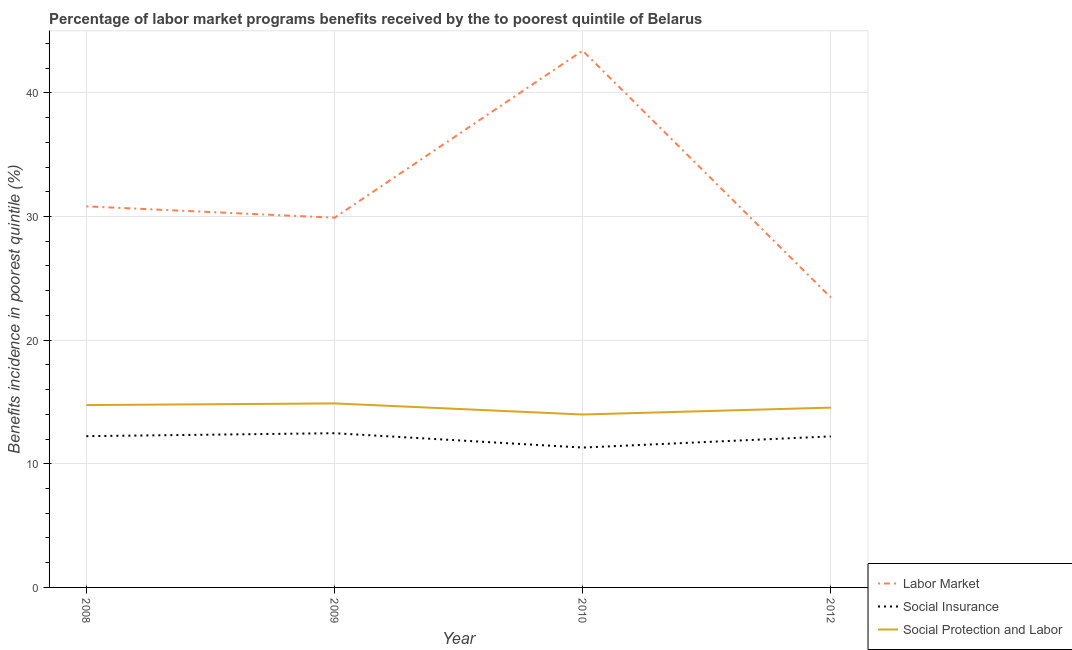What is the percentage of benefits received due to labor market programs in 2008?
Your answer should be compact. 30.82. Across all years, what is the maximum percentage of benefits received due to social insurance programs?
Provide a short and direct response. 12.47. Across all years, what is the minimum percentage of benefits received due to labor market programs?
Your answer should be compact. 23.45. In which year was the percentage of benefits received due to social insurance programs minimum?
Your response must be concise. 2010. What is the total percentage of benefits received due to social insurance programs in the graph?
Your answer should be compact. 48.24. What is the difference between the percentage of benefits received due to social protection programs in 2009 and that in 2010?
Make the answer very short. 0.9. What is the difference between the percentage of benefits received due to social protection programs in 2012 and the percentage of benefits received due to social insurance programs in 2010?
Provide a short and direct response. 3.23. What is the average percentage of benefits received due to social protection programs per year?
Provide a succinct answer. 14.54. In the year 2010, what is the difference between the percentage of benefits received due to labor market programs and percentage of benefits received due to social protection programs?
Ensure brevity in your answer.  29.43. In how many years, is the percentage of benefits received due to labor market programs greater than 8 %?
Keep it short and to the point. 4. What is the ratio of the percentage of benefits received due to social protection programs in 2008 to that in 2010?
Make the answer very short. 1.05. Is the percentage of benefits received due to social insurance programs in 2008 less than that in 2010?
Your response must be concise. No. What is the difference between the highest and the second highest percentage of benefits received due to labor market programs?
Your response must be concise. 12.59. What is the difference between the highest and the lowest percentage of benefits received due to labor market programs?
Offer a very short reply. 19.96. In how many years, is the percentage of benefits received due to labor market programs greater than the average percentage of benefits received due to labor market programs taken over all years?
Your answer should be compact. 1. Does the percentage of benefits received due to social insurance programs monotonically increase over the years?
Offer a terse response. No. Is the percentage of benefits received due to labor market programs strictly greater than the percentage of benefits received due to social protection programs over the years?
Your answer should be very brief. Yes. Is the percentage of benefits received due to social insurance programs strictly less than the percentage of benefits received due to social protection programs over the years?
Offer a terse response. Yes. How many lines are there?
Offer a terse response. 3. How many years are there in the graph?
Provide a succinct answer. 4. Are the values on the major ticks of Y-axis written in scientific E-notation?
Offer a terse response. No. Does the graph contain any zero values?
Provide a succinct answer. No. Does the graph contain grids?
Keep it short and to the point. Yes. Where does the legend appear in the graph?
Your answer should be very brief. Bottom right. How many legend labels are there?
Your response must be concise. 3. How are the legend labels stacked?
Make the answer very short. Vertical. What is the title of the graph?
Make the answer very short. Percentage of labor market programs benefits received by the to poorest quintile of Belarus. What is the label or title of the Y-axis?
Provide a succinct answer. Benefits incidence in poorest quintile (%). What is the Benefits incidence in poorest quintile (%) in Labor Market in 2008?
Offer a terse response. 30.82. What is the Benefits incidence in poorest quintile (%) in Social Insurance in 2008?
Provide a succinct answer. 12.24. What is the Benefits incidence in poorest quintile (%) of Social Protection and Labor in 2008?
Offer a very short reply. 14.75. What is the Benefits incidence in poorest quintile (%) in Labor Market in 2009?
Provide a short and direct response. 29.9. What is the Benefits incidence in poorest quintile (%) of Social Insurance in 2009?
Provide a short and direct response. 12.47. What is the Benefits incidence in poorest quintile (%) in Social Protection and Labor in 2009?
Offer a terse response. 14.89. What is the Benefits incidence in poorest quintile (%) of Labor Market in 2010?
Provide a succinct answer. 43.42. What is the Benefits incidence in poorest quintile (%) of Social Insurance in 2010?
Provide a succinct answer. 11.31. What is the Benefits incidence in poorest quintile (%) in Social Protection and Labor in 2010?
Offer a very short reply. 13.99. What is the Benefits incidence in poorest quintile (%) in Labor Market in 2012?
Make the answer very short. 23.45. What is the Benefits incidence in poorest quintile (%) of Social Insurance in 2012?
Your response must be concise. 12.22. What is the Benefits incidence in poorest quintile (%) in Social Protection and Labor in 2012?
Offer a terse response. 14.54. Across all years, what is the maximum Benefits incidence in poorest quintile (%) in Labor Market?
Provide a succinct answer. 43.42. Across all years, what is the maximum Benefits incidence in poorest quintile (%) in Social Insurance?
Give a very brief answer. 12.47. Across all years, what is the maximum Benefits incidence in poorest quintile (%) of Social Protection and Labor?
Ensure brevity in your answer.  14.89. Across all years, what is the minimum Benefits incidence in poorest quintile (%) in Labor Market?
Your answer should be compact. 23.45. Across all years, what is the minimum Benefits incidence in poorest quintile (%) of Social Insurance?
Give a very brief answer. 11.31. Across all years, what is the minimum Benefits incidence in poorest quintile (%) of Social Protection and Labor?
Provide a short and direct response. 13.99. What is the total Benefits incidence in poorest quintile (%) of Labor Market in the graph?
Provide a succinct answer. 127.6. What is the total Benefits incidence in poorest quintile (%) in Social Insurance in the graph?
Your response must be concise. 48.24. What is the total Benefits incidence in poorest quintile (%) in Social Protection and Labor in the graph?
Keep it short and to the point. 58.16. What is the difference between the Benefits incidence in poorest quintile (%) in Labor Market in 2008 and that in 2009?
Your response must be concise. 0.92. What is the difference between the Benefits incidence in poorest quintile (%) in Social Insurance in 2008 and that in 2009?
Your answer should be compact. -0.24. What is the difference between the Benefits incidence in poorest quintile (%) of Social Protection and Labor in 2008 and that in 2009?
Your answer should be very brief. -0.14. What is the difference between the Benefits incidence in poorest quintile (%) of Labor Market in 2008 and that in 2010?
Your answer should be compact. -12.59. What is the difference between the Benefits incidence in poorest quintile (%) in Social Insurance in 2008 and that in 2010?
Your answer should be compact. 0.92. What is the difference between the Benefits incidence in poorest quintile (%) in Social Protection and Labor in 2008 and that in 2010?
Your answer should be very brief. 0.76. What is the difference between the Benefits incidence in poorest quintile (%) of Labor Market in 2008 and that in 2012?
Provide a short and direct response. 7.37. What is the difference between the Benefits incidence in poorest quintile (%) in Social Insurance in 2008 and that in 2012?
Offer a very short reply. 0.02. What is the difference between the Benefits incidence in poorest quintile (%) in Social Protection and Labor in 2008 and that in 2012?
Keep it short and to the point. 0.2. What is the difference between the Benefits incidence in poorest quintile (%) in Labor Market in 2009 and that in 2010?
Offer a terse response. -13.51. What is the difference between the Benefits incidence in poorest quintile (%) in Social Insurance in 2009 and that in 2010?
Your answer should be compact. 1.16. What is the difference between the Benefits incidence in poorest quintile (%) in Social Protection and Labor in 2009 and that in 2010?
Your answer should be compact. 0.9. What is the difference between the Benefits incidence in poorest quintile (%) in Labor Market in 2009 and that in 2012?
Ensure brevity in your answer.  6.45. What is the difference between the Benefits incidence in poorest quintile (%) in Social Insurance in 2009 and that in 2012?
Offer a very short reply. 0.26. What is the difference between the Benefits incidence in poorest quintile (%) in Social Protection and Labor in 2009 and that in 2012?
Offer a very short reply. 0.34. What is the difference between the Benefits incidence in poorest quintile (%) in Labor Market in 2010 and that in 2012?
Give a very brief answer. 19.96. What is the difference between the Benefits incidence in poorest quintile (%) in Social Insurance in 2010 and that in 2012?
Provide a succinct answer. -0.9. What is the difference between the Benefits incidence in poorest quintile (%) in Social Protection and Labor in 2010 and that in 2012?
Give a very brief answer. -0.56. What is the difference between the Benefits incidence in poorest quintile (%) in Labor Market in 2008 and the Benefits incidence in poorest quintile (%) in Social Insurance in 2009?
Provide a short and direct response. 18.35. What is the difference between the Benefits incidence in poorest quintile (%) of Labor Market in 2008 and the Benefits incidence in poorest quintile (%) of Social Protection and Labor in 2009?
Offer a terse response. 15.94. What is the difference between the Benefits incidence in poorest quintile (%) in Social Insurance in 2008 and the Benefits incidence in poorest quintile (%) in Social Protection and Labor in 2009?
Keep it short and to the point. -2.65. What is the difference between the Benefits incidence in poorest quintile (%) of Labor Market in 2008 and the Benefits incidence in poorest quintile (%) of Social Insurance in 2010?
Keep it short and to the point. 19.51. What is the difference between the Benefits incidence in poorest quintile (%) in Labor Market in 2008 and the Benefits incidence in poorest quintile (%) in Social Protection and Labor in 2010?
Make the answer very short. 16.84. What is the difference between the Benefits incidence in poorest quintile (%) of Social Insurance in 2008 and the Benefits incidence in poorest quintile (%) of Social Protection and Labor in 2010?
Keep it short and to the point. -1.75. What is the difference between the Benefits incidence in poorest quintile (%) in Labor Market in 2008 and the Benefits incidence in poorest quintile (%) in Social Insurance in 2012?
Give a very brief answer. 18.61. What is the difference between the Benefits incidence in poorest quintile (%) in Labor Market in 2008 and the Benefits incidence in poorest quintile (%) in Social Protection and Labor in 2012?
Provide a short and direct response. 16.28. What is the difference between the Benefits incidence in poorest quintile (%) of Social Insurance in 2008 and the Benefits incidence in poorest quintile (%) of Social Protection and Labor in 2012?
Your response must be concise. -2.31. What is the difference between the Benefits incidence in poorest quintile (%) in Labor Market in 2009 and the Benefits incidence in poorest quintile (%) in Social Insurance in 2010?
Your response must be concise. 18.59. What is the difference between the Benefits incidence in poorest quintile (%) in Labor Market in 2009 and the Benefits incidence in poorest quintile (%) in Social Protection and Labor in 2010?
Give a very brief answer. 15.92. What is the difference between the Benefits incidence in poorest quintile (%) of Social Insurance in 2009 and the Benefits incidence in poorest quintile (%) of Social Protection and Labor in 2010?
Offer a very short reply. -1.51. What is the difference between the Benefits incidence in poorest quintile (%) in Labor Market in 2009 and the Benefits incidence in poorest quintile (%) in Social Insurance in 2012?
Your answer should be very brief. 17.69. What is the difference between the Benefits incidence in poorest quintile (%) in Labor Market in 2009 and the Benefits incidence in poorest quintile (%) in Social Protection and Labor in 2012?
Provide a short and direct response. 15.36. What is the difference between the Benefits incidence in poorest quintile (%) in Social Insurance in 2009 and the Benefits incidence in poorest quintile (%) in Social Protection and Labor in 2012?
Keep it short and to the point. -2.07. What is the difference between the Benefits incidence in poorest quintile (%) of Labor Market in 2010 and the Benefits incidence in poorest quintile (%) of Social Insurance in 2012?
Your answer should be very brief. 31.2. What is the difference between the Benefits incidence in poorest quintile (%) in Labor Market in 2010 and the Benefits incidence in poorest quintile (%) in Social Protection and Labor in 2012?
Your answer should be compact. 28.87. What is the difference between the Benefits incidence in poorest quintile (%) in Social Insurance in 2010 and the Benefits incidence in poorest quintile (%) in Social Protection and Labor in 2012?
Keep it short and to the point. -3.23. What is the average Benefits incidence in poorest quintile (%) in Labor Market per year?
Offer a terse response. 31.9. What is the average Benefits incidence in poorest quintile (%) of Social Insurance per year?
Your answer should be compact. 12.06. What is the average Benefits incidence in poorest quintile (%) in Social Protection and Labor per year?
Keep it short and to the point. 14.54. In the year 2008, what is the difference between the Benefits incidence in poorest quintile (%) in Labor Market and Benefits incidence in poorest quintile (%) in Social Insurance?
Keep it short and to the point. 18.59. In the year 2008, what is the difference between the Benefits incidence in poorest quintile (%) of Labor Market and Benefits incidence in poorest quintile (%) of Social Protection and Labor?
Provide a short and direct response. 16.07. In the year 2008, what is the difference between the Benefits incidence in poorest quintile (%) of Social Insurance and Benefits incidence in poorest quintile (%) of Social Protection and Labor?
Your response must be concise. -2.51. In the year 2009, what is the difference between the Benefits incidence in poorest quintile (%) of Labor Market and Benefits incidence in poorest quintile (%) of Social Insurance?
Your answer should be compact. 17.43. In the year 2009, what is the difference between the Benefits incidence in poorest quintile (%) in Labor Market and Benefits incidence in poorest quintile (%) in Social Protection and Labor?
Keep it short and to the point. 15.02. In the year 2009, what is the difference between the Benefits incidence in poorest quintile (%) of Social Insurance and Benefits incidence in poorest quintile (%) of Social Protection and Labor?
Keep it short and to the point. -2.41. In the year 2010, what is the difference between the Benefits incidence in poorest quintile (%) in Labor Market and Benefits incidence in poorest quintile (%) in Social Insurance?
Keep it short and to the point. 32.1. In the year 2010, what is the difference between the Benefits incidence in poorest quintile (%) in Labor Market and Benefits incidence in poorest quintile (%) in Social Protection and Labor?
Keep it short and to the point. 29.43. In the year 2010, what is the difference between the Benefits incidence in poorest quintile (%) in Social Insurance and Benefits incidence in poorest quintile (%) in Social Protection and Labor?
Give a very brief answer. -2.67. In the year 2012, what is the difference between the Benefits incidence in poorest quintile (%) of Labor Market and Benefits incidence in poorest quintile (%) of Social Insurance?
Offer a very short reply. 11.24. In the year 2012, what is the difference between the Benefits incidence in poorest quintile (%) of Labor Market and Benefits incidence in poorest quintile (%) of Social Protection and Labor?
Make the answer very short. 8.91. In the year 2012, what is the difference between the Benefits incidence in poorest quintile (%) in Social Insurance and Benefits incidence in poorest quintile (%) in Social Protection and Labor?
Keep it short and to the point. -2.33. What is the ratio of the Benefits incidence in poorest quintile (%) of Labor Market in 2008 to that in 2009?
Offer a terse response. 1.03. What is the ratio of the Benefits incidence in poorest quintile (%) in Social Insurance in 2008 to that in 2009?
Ensure brevity in your answer.  0.98. What is the ratio of the Benefits incidence in poorest quintile (%) of Labor Market in 2008 to that in 2010?
Your response must be concise. 0.71. What is the ratio of the Benefits incidence in poorest quintile (%) in Social Insurance in 2008 to that in 2010?
Your answer should be very brief. 1.08. What is the ratio of the Benefits incidence in poorest quintile (%) in Social Protection and Labor in 2008 to that in 2010?
Make the answer very short. 1.05. What is the ratio of the Benefits incidence in poorest quintile (%) of Labor Market in 2008 to that in 2012?
Offer a very short reply. 1.31. What is the ratio of the Benefits incidence in poorest quintile (%) of Social Protection and Labor in 2008 to that in 2012?
Provide a short and direct response. 1.01. What is the ratio of the Benefits incidence in poorest quintile (%) in Labor Market in 2009 to that in 2010?
Offer a terse response. 0.69. What is the ratio of the Benefits incidence in poorest quintile (%) of Social Insurance in 2009 to that in 2010?
Your answer should be very brief. 1.1. What is the ratio of the Benefits incidence in poorest quintile (%) in Social Protection and Labor in 2009 to that in 2010?
Keep it short and to the point. 1.06. What is the ratio of the Benefits incidence in poorest quintile (%) of Labor Market in 2009 to that in 2012?
Ensure brevity in your answer.  1.27. What is the ratio of the Benefits incidence in poorest quintile (%) of Social Insurance in 2009 to that in 2012?
Your answer should be very brief. 1.02. What is the ratio of the Benefits incidence in poorest quintile (%) in Social Protection and Labor in 2009 to that in 2012?
Give a very brief answer. 1.02. What is the ratio of the Benefits incidence in poorest quintile (%) in Labor Market in 2010 to that in 2012?
Keep it short and to the point. 1.85. What is the ratio of the Benefits incidence in poorest quintile (%) of Social Insurance in 2010 to that in 2012?
Provide a succinct answer. 0.93. What is the ratio of the Benefits incidence in poorest quintile (%) in Social Protection and Labor in 2010 to that in 2012?
Ensure brevity in your answer.  0.96. What is the difference between the highest and the second highest Benefits incidence in poorest quintile (%) in Labor Market?
Your answer should be compact. 12.59. What is the difference between the highest and the second highest Benefits incidence in poorest quintile (%) in Social Insurance?
Your response must be concise. 0.24. What is the difference between the highest and the second highest Benefits incidence in poorest quintile (%) in Social Protection and Labor?
Your response must be concise. 0.14. What is the difference between the highest and the lowest Benefits incidence in poorest quintile (%) in Labor Market?
Offer a very short reply. 19.96. What is the difference between the highest and the lowest Benefits incidence in poorest quintile (%) in Social Insurance?
Provide a short and direct response. 1.16. What is the difference between the highest and the lowest Benefits incidence in poorest quintile (%) of Social Protection and Labor?
Keep it short and to the point. 0.9. 